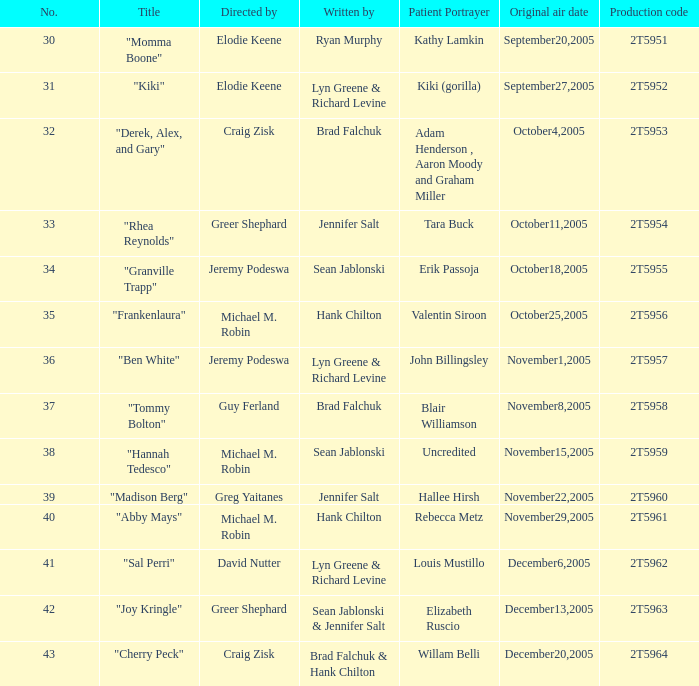Who is the author of the episode with the production code 2t5954? Jennifer Salt. 